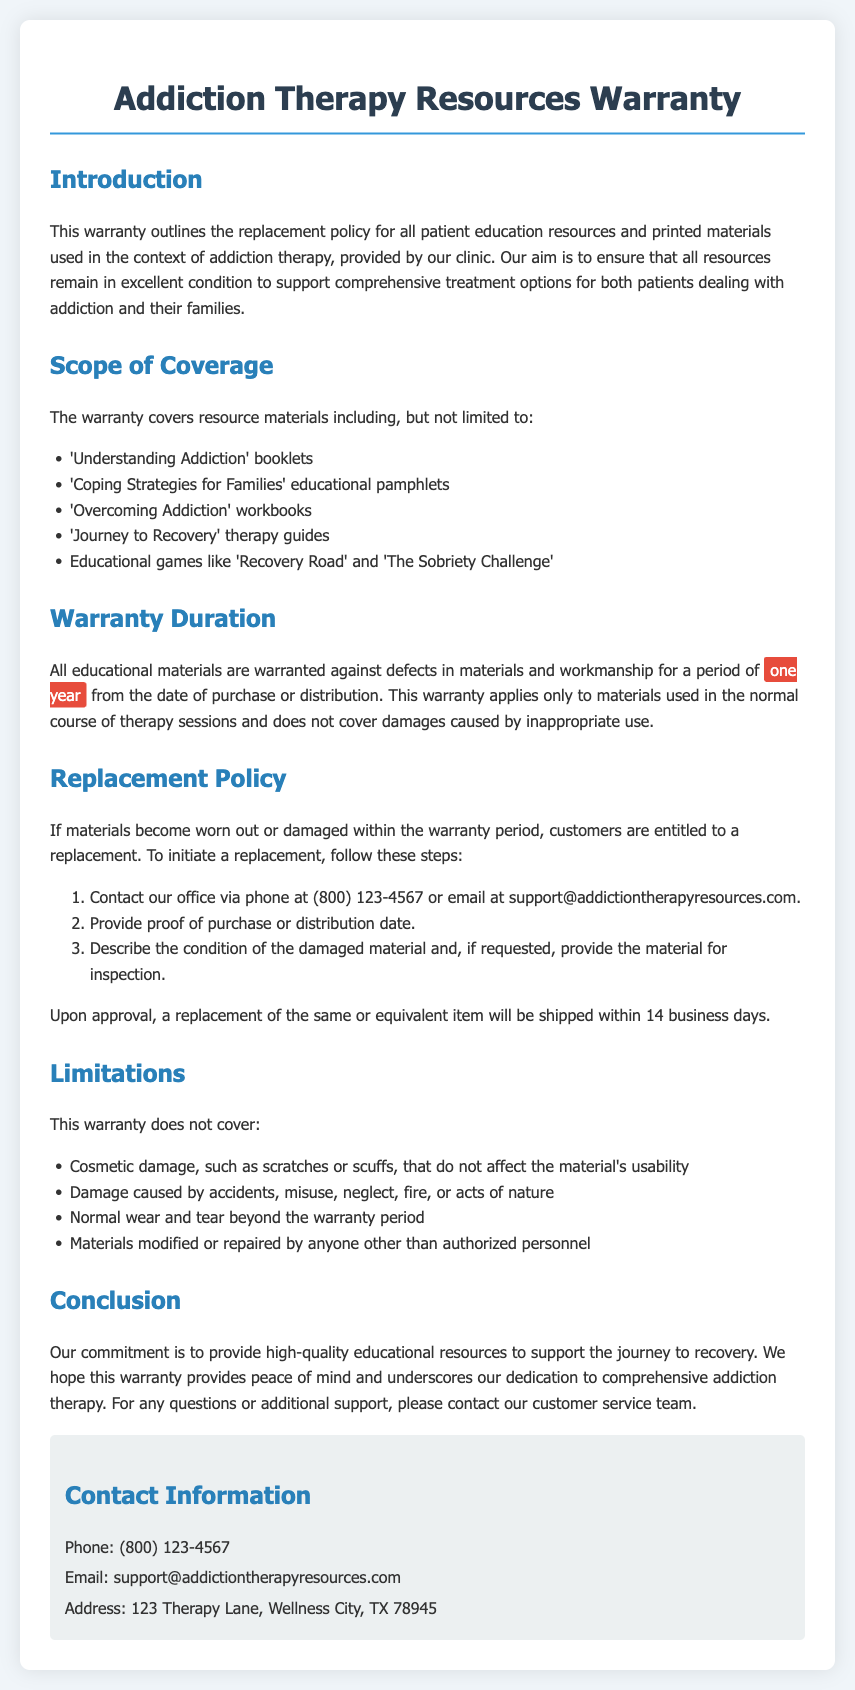what is the warranty duration? The warranty duration is specified in the document as the period during which the materials are protected against defects.
Answer: one year what materials are covered under this warranty? The document lists specific resources that are included in the warranty coverage.
Answer: 'Understanding Addiction' booklets how long will it take to receive a replacement? The document states the time frame for the replacement shipment after approval.
Answer: 14 business days what should you provide to initiate a replacement? The document outlines the necessary steps to begin the replacement process, including specific information.
Answer: proof of purchase what damages are not covered by this warranty? The document describes limitations on the warranty and what types of damage are excluded.
Answer: Cosmetic damage who is the contact person for support? The document provides contact information, including a method of communication for customer inquiries.
Answer: customer service team where is the office located? The warranty document mentions the physical address of the office for customer support.
Answer: 123 Therapy Lane, Wellness City, TX 78945 what types of educational games are included in the warranty? The warranty covers specific types of educational materials, and the document lists examples.
Answer: 'Recovery Road' and 'The Sobriety Challenge' 